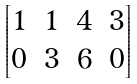Convert formula to latex. <formula><loc_0><loc_0><loc_500><loc_500>\begin{bmatrix} 1 & 1 & 4 & 3 \\ 0 & 3 & 6 & 0 \end{bmatrix}</formula> 